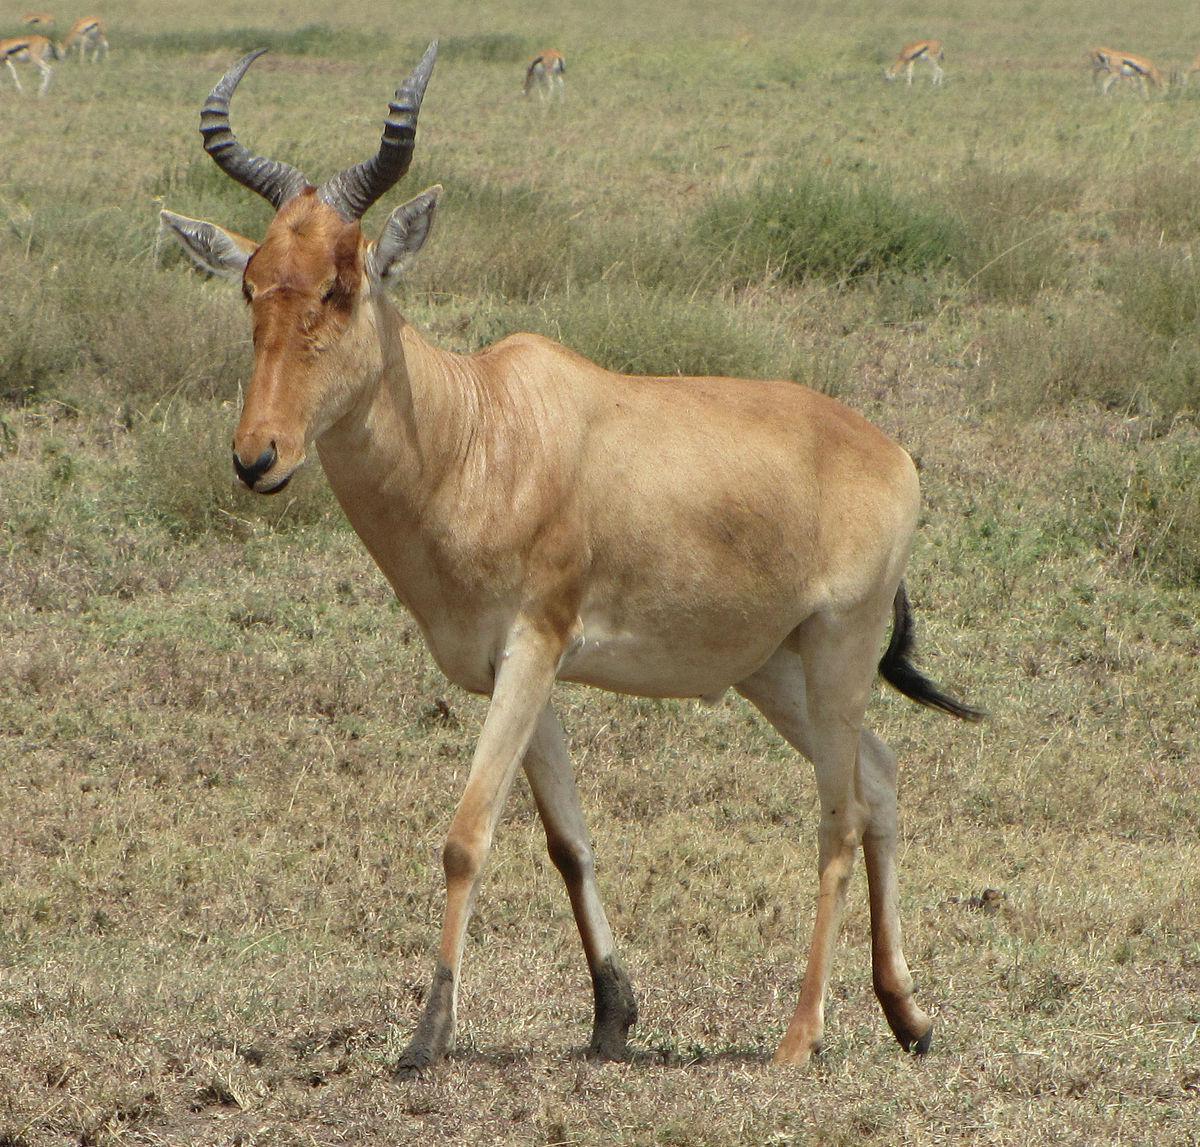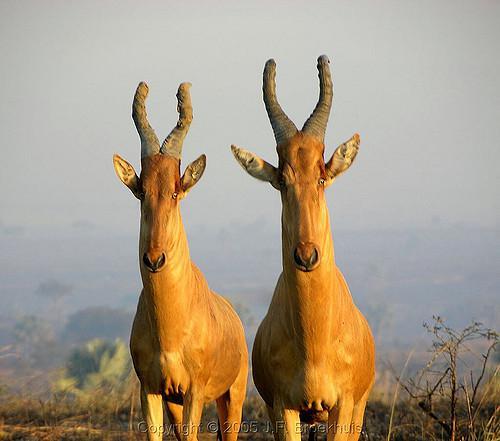The first image is the image on the left, the second image is the image on the right. Considering the images on both sides, is "There is exactly one animal in the image on the right." valid? Answer yes or no. No. 